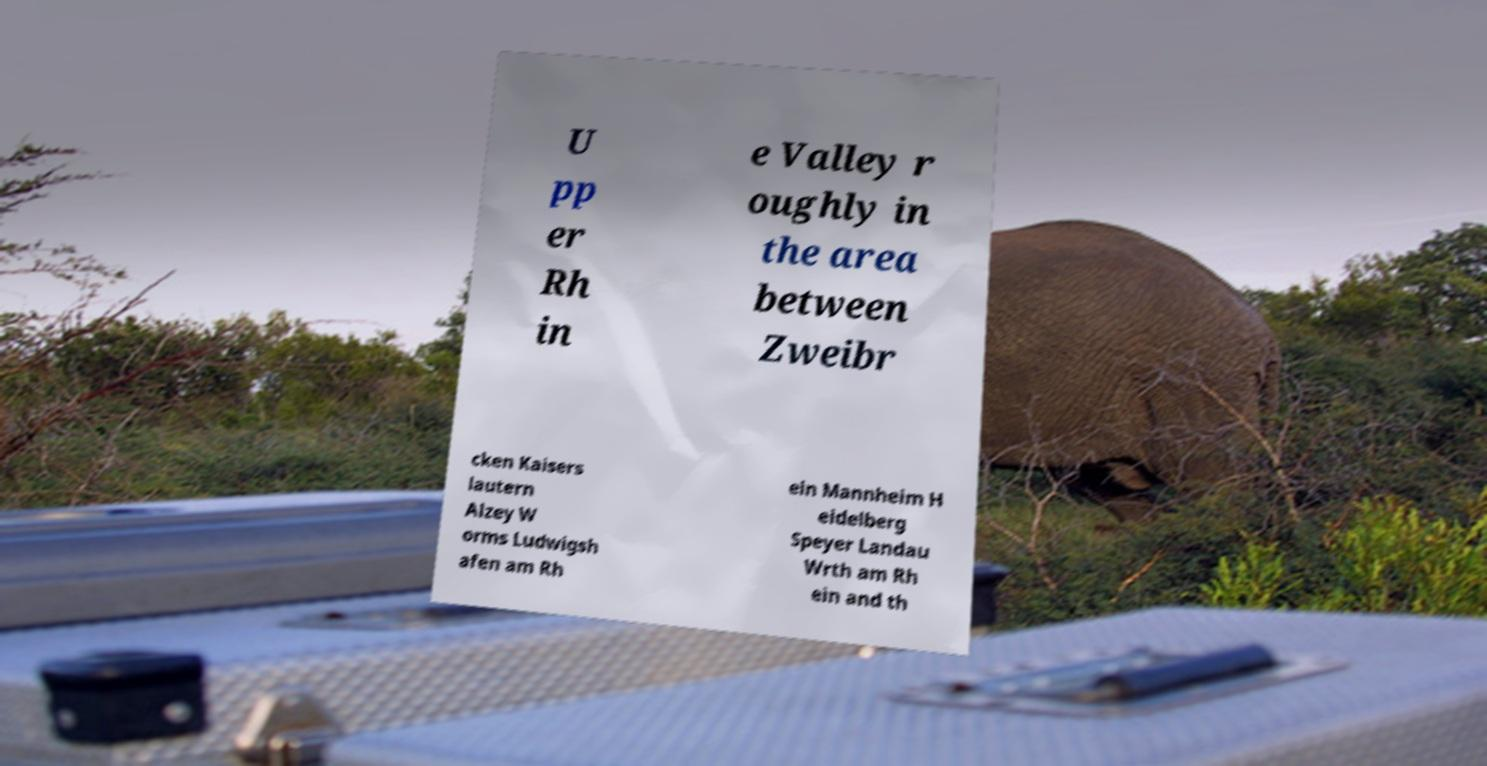Could you extract and type out the text from this image? U pp er Rh in e Valley r oughly in the area between Zweibr cken Kaisers lautern Alzey W orms Ludwigsh afen am Rh ein Mannheim H eidelberg Speyer Landau Wrth am Rh ein and th 